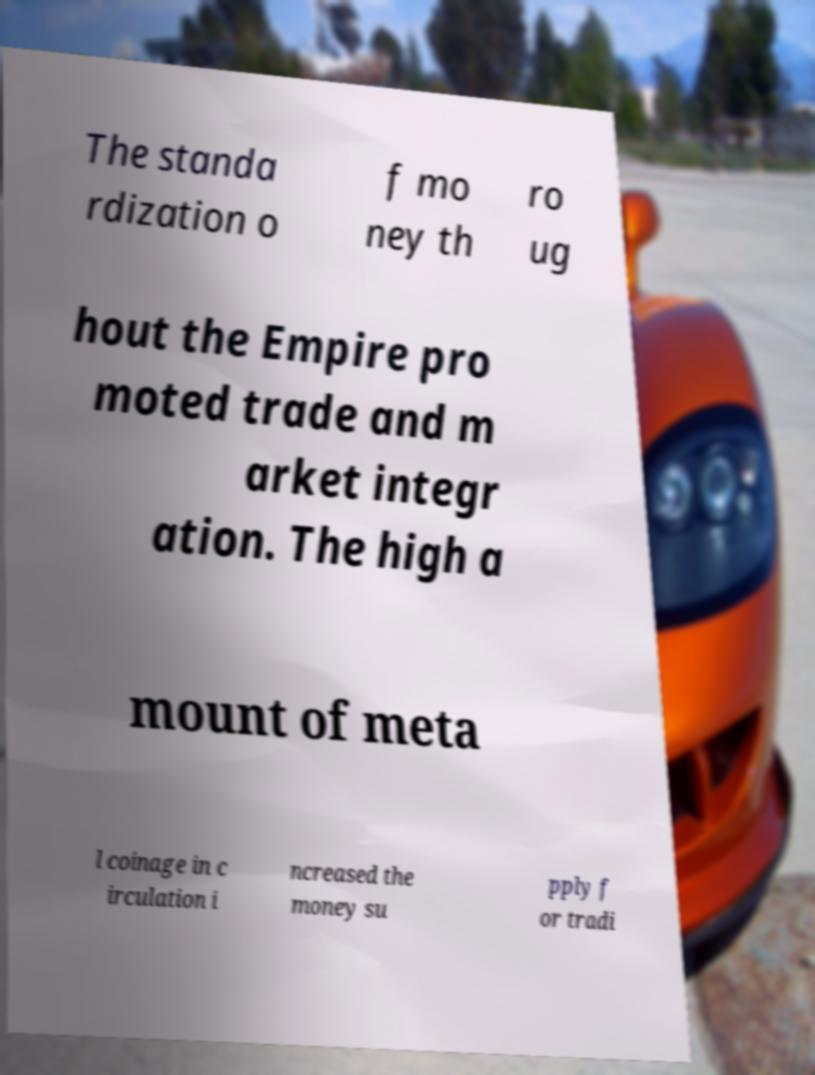There's text embedded in this image that I need extracted. Can you transcribe it verbatim? The standa rdization o f mo ney th ro ug hout the Empire pro moted trade and m arket integr ation. The high a mount of meta l coinage in c irculation i ncreased the money su pply f or tradi 